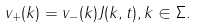<formula> <loc_0><loc_0><loc_500><loc_500>v _ { + } ( k ) = v _ { - } ( k ) J ( k , t ) , k \in \Sigma .</formula> 